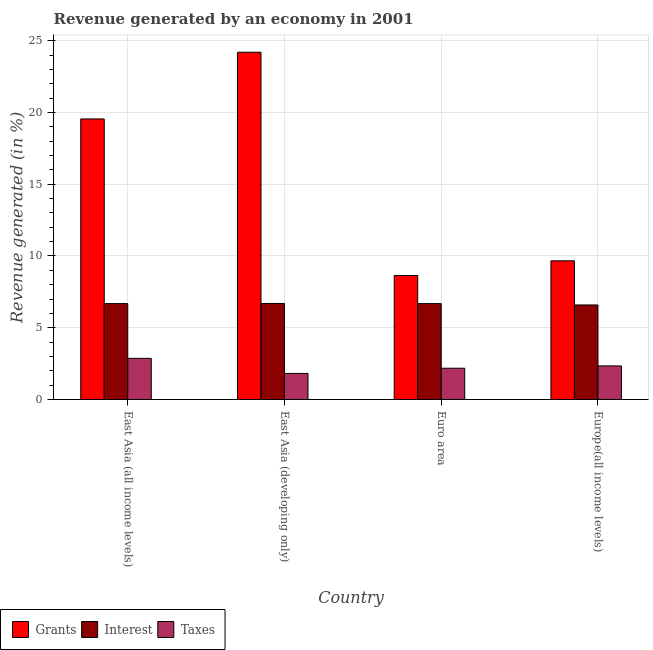How many different coloured bars are there?
Ensure brevity in your answer.  3. Are the number of bars per tick equal to the number of legend labels?
Your answer should be very brief. Yes. Are the number of bars on each tick of the X-axis equal?
Offer a very short reply. Yes. How many bars are there on the 2nd tick from the left?
Offer a terse response. 3. How many bars are there on the 1st tick from the right?
Offer a very short reply. 3. What is the label of the 3rd group of bars from the left?
Your answer should be very brief. Euro area. In how many cases, is the number of bars for a given country not equal to the number of legend labels?
Your answer should be compact. 0. What is the percentage of revenue generated by taxes in Euro area?
Give a very brief answer. 2.18. Across all countries, what is the maximum percentage of revenue generated by grants?
Offer a terse response. 24.19. Across all countries, what is the minimum percentage of revenue generated by interest?
Provide a short and direct response. 6.59. In which country was the percentage of revenue generated by grants maximum?
Ensure brevity in your answer.  East Asia (developing only). In which country was the percentage of revenue generated by grants minimum?
Provide a short and direct response. Euro area. What is the total percentage of revenue generated by grants in the graph?
Your response must be concise. 62.04. What is the difference between the percentage of revenue generated by taxes in East Asia (all income levels) and that in Europe(all income levels)?
Give a very brief answer. 0.53. What is the difference between the percentage of revenue generated by taxes in East Asia (developing only) and the percentage of revenue generated by grants in Europe(all income levels)?
Your response must be concise. -7.85. What is the average percentage of revenue generated by grants per country?
Offer a terse response. 15.51. What is the difference between the percentage of revenue generated by interest and percentage of revenue generated by grants in Europe(all income levels)?
Your response must be concise. -3.08. What is the ratio of the percentage of revenue generated by grants in East Asia (all income levels) to that in East Asia (developing only)?
Offer a very short reply. 0.81. What is the difference between the highest and the second highest percentage of revenue generated by taxes?
Provide a succinct answer. 0.53. What is the difference between the highest and the lowest percentage of revenue generated by taxes?
Your answer should be very brief. 1.05. What does the 2nd bar from the left in Euro area represents?
Offer a terse response. Interest. What does the 3rd bar from the right in Europe(all income levels) represents?
Your answer should be very brief. Grants. How many bars are there?
Give a very brief answer. 12. Are all the bars in the graph horizontal?
Keep it short and to the point. No. Are the values on the major ticks of Y-axis written in scientific E-notation?
Provide a short and direct response. No. Does the graph contain any zero values?
Provide a succinct answer. No. Does the graph contain grids?
Keep it short and to the point. Yes. How many legend labels are there?
Your response must be concise. 3. How are the legend labels stacked?
Provide a succinct answer. Horizontal. What is the title of the graph?
Provide a succinct answer. Revenue generated by an economy in 2001. What is the label or title of the X-axis?
Offer a terse response. Country. What is the label or title of the Y-axis?
Ensure brevity in your answer.  Revenue generated (in %). What is the Revenue generated (in %) of Grants in East Asia (all income levels)?
Provide a short and direct response. 19.55. What is the Revenue generated (in %) in Interest in East Asia (all income levels)?
Offer a very short reply. 6.68. What is the Revenue generated (in %) in Taxes in East Asia (all income levels)?
Provide a succinct answer. 2.87. What is the Revenue generated (in %) in Grants in East Asia (developing only)?
Your response must be concise. 24.19. What is the Revenue generated (in %) in Interest in East Asia (developing only)?
Ensure brevity in your answer.  6.69. What is the Revenue generated (in %) in Taxes in East Asia (developing only)?
Your answer should be very brief. 1.82. What is the Revenue generated (in %) of Grants in Euro area?
Your answer should be compact. 8.64. What is the Revenue generated (in %) of Interest in Euro area?
Give a very brief answer. 6.68. What is the Revenue generated (in %) of Taxes in Euro area?
Your response must be concise. 2.18. What is the Revenue generated (in %) in Grants in Europe(all income levels)?
Keep it short and to the point. 9.66. What is the Revenue generated (in %) in Interest in Europe(all income levels)?
Your response must be concise. 6.59. What is the Revenue generated (in %) in Taxes in Europe(all income levels)?
Offer a very short reply. 2.34. Across all countries, what is the maximum Revenue generated (in %) in Grants?
Your response must be concise. 24.19. Across all countries, what is the maximum Revenue generated (in %) in Interest?
Give a very brief answer. 6.69. Across all countries, what is the maximum Revenue generated (in %) in Taxes?
Provide a succinct answer. 2.87. Across all countries, what is the minimum Revenue generated (in %) in Grants?
Provide a short and direct response. 8.64. Across all countries, what is the minimum Revenue generated (in %) in Interest?
Provide a succinct answer. 6.59. Across all countries, what is the minimum Revenue generated (in %) in Taxes?
Provide a short and direct response. 1.82. What is the total Revenue generated (in %) of Grants in the graph?
Keep it short and to the point. 62.04. What is the total Revenue generated (in %) in Interest in the graph?
Your response must be concise. 26.64. What is the total Revenue generated (in %) in Taxes in the graph?
Offer a terse response. 9.21. What is the difference between the Revenue generated (in %) in Grants in East Asia (all income levels) and that in East Asia (developing only)?
Keep it short and to the point. -4.65. What is the difference between the Revenue generated (in %) in Interest in East Asia (all income levels) and that in East Asia (developing only)?
Keep it short and to the point. -0.01. What is the difference between the Revenue generated (in %) in Taxes in East Asia (all income levels) and that in East Asia (developing only)?
Provide a short and direct response. 1.05. What is the difference between the Revenue generated (in %) of Grants in East Asia (all income levels) and that in Euro area?
Provide a succinct answer. 10.91. What is the difference between the Revenue generated (in %) in Taxes in East Asia (all income levels) and that in Euro area?
Your answer should be compact. 0.69. What is the difference between the Revenue generated (in %) in Grants in East Asia (all income levels) and that in Europe(all income levels)?
Provide a succinct answer. 9.88. What is the difference between the Revenue generated (in %) in Interest in East Asia (all income levels) and that in Europe(all income levels)?
Offer a terse response. 0.09. What is the difference between the Revenue generated (in %) of Taxes in East Asia (all income levels) and that in Europe(all income levels)?
Make the answer very short. 0.53. What is the difference between the Revenue generated (in %) of Grants in East Asia (developing only) and that in Euro area?
Offer a very short reply. 15.55. What is the difference between the Revenue generated (in %) of Interest in East Asia (developing only) and that in Euro area?
Make the answer very short. 0.01. What is the difference between the Revenue generated (in %) of Taxes in East Asia (developing only) and that in Euro area?
Provide a succinct answer. -0.36. What is the difference between the Revenue generated (in %) in Grants in East Asia (developing only) and that in Europe(all income levels)?
Give a very brief answer. 14.53. What is the difference between the Revenue generated (in %) of Interest in East Asia (developing only) and that in Europe(all income levels)?
Your answer should be compact. 0.1. What is the difference between the Revenue generated (in %) in Taxes in East Asia (developing only) and that in Europe(all income levels)?
Ensure brevity in your answer.  -0.52. What is the difference between the Revenue generated (in %) of Grants in Euro area and that in Europe(all income levels)?
Your answer should be very brief. -1.02. What is the difference between the Revenue generated (in %) of Interest in Euro area and that in Europe(all income levels)?
Ensure brevity in your answer.  0.09. What is the difference between the Revenue generated (in %) in Taxes in Euro area and that in Europe(all income levels)?
Offer a very short reply. -0.16. What is the difference between the Revenue generated (in %) in Grants in East Asia (all income levels) and the Revenue generated (in %) in Interest in East Asia (developing only)?
Ensure brevity in your answer.  12.85. What is the difference between the Revenue generated (in %) in Grants in East Asia (all income levels) and the Revenue generated (in %) in Taxes in East Asia (developing only)?
Make the answer very short. 17.73. What is the difference between the Revenue generated (in %) of Interest in East Asia (all income levels) and the Revenue generated (in %) of Taxes in East Asia (developing only)?
Provide a succinct answer. 4.86. What is the difference between the Revenue generated (in %) in Grants in East Asia (all income levels) and the Revenue generated (in %) in Interest in Euro area?
Make the answer very short. 12.86. What is the difference between the Revenue generated (in %) in Grants in East Asia (all income levels) and the Revenue generated (in %) in Taxes in Euro area?
Offer a terse response. 17.37. What is the difference between the Revenue generated (in %) in Interest in East Asia (all income levels) and the Revenue generated (in %) in Taxes in Euro area?
Make the answer very short. 4.5. What is the difference between the Revenue generated (in %) of Grants in East Asia (all income levels) and the Revenue generated (in %) of Interest in Europe(all income levels)?
Your answer should be compact. 12.96. What is the difference between the Revenue generated (in %) in Grants in East Asia (all income levels) and the Revenue generated (in %) in Taxes in Europe(all income levels)?
Ensure brevity in your answer.  17.2. What is the difference between the Revenue generated (in %) in Interest in East Asia (all income levels) and the Revenue generated (in %) in Taxes in Europe(all income levels)?
Provide a succinct answer. 4.34. What is the difference between the Revenue generated (in %) in Grants in East Asia (developing only) and the Revenue generated (in %) in Interest in Euro area?
Keep it short and to the point. 17.51. What is the difference between the Revenue generated (in %) of Grants in East Asia (developing only) and the Revenue generated (in %) of Taxes in Euro area?
Your response must be concise. 22.01. What is the difference between the Revenue generated (in %) in Interest in East Asia (developing only) and the Revenue generated (in %) in Taxes in Euro area?
Offer a very short reply. 4.51. What is the difference between the Revenue generated (in %) of Grants in East Asia (developing only) and the Revenue generated (in %) of Interest in Europe(all income levels)?
Provide a succinct answer. 17.61. What is the difference between the Revenue generated (in %) of Grants in East Asia (developing only) and the Revenue generated (in %) of Taxes in Europe(all income levels)?
Offer a terse response. 21.85. What is the difference between the Revenue generated (in %) of Interest in East Asia (developing only) and the Revenue generated (in %) of Taxes in Europe(all income levels)?
Your answer should be very brief. 4.35. What is the difference between the Revenue generated (in %) in Grants in Euro area and the Revenue generated (in %) in Interest in Europe(all income levels)?
Give a very brief answer. 2.05. What is the difference between the Revenue generated (in %) in Grants in Euro area and the Revenue generated (in %) in Taxes in Europe(all income levels)?
Your answer should be compact. 6.3. What is the difference between the Revenue generated (in %) of Interest in Euro area and the Revenue generated (in %) of Taxes in Europe(all income levels)?
Offer a very short reply. 4.34. What is the average Revenue generated (in %) of Grants per country?
Ensure brevity in your answer.  15.51. What is the average Revenue generated (in %) of Interest per country?
Make the answer very short. 6.66. What is the average Revenue generated (in %) in Taxes per country?
Your response must be concise. 2.3. What is the difference between the Revenue generated (in %) in Grants and Revenue generated (in %) in Interest in East Asia (all income levels)?
Give a very brief answer. 12.86. What is the difference between the Revenue generated (in %) of Grants and Revenue generated (in %) of Taxes in East Asia (all income levels)?
Provide a short and direct response. 16.68. What is the difference between the Revenue generated (in %) in Interest and Revenue generated (in %) in Taxes in East Asia (all income levels)?
Your answer should be compact. 3.81. What is the difference between the Revenue generated (in %) in Grants and Revenue generated (in %) in Interest in East Asia (developing only)?
Your response must be concise. 17.5. What is the difference between the Revenue generated (in %) of Grants and Revenue generated (in %) of Taxes in East Asia (developing only)?
Offer a very short reply. 22.38. What is the difference between the Revenue generated (in %) in Interest and Revenue generated (in %) in Taxes in East Asia (developing only)?
Make the answer very short. 4.87. What is the difference between the Revenue generated (in %) in Grants and Revenue generated (in %) in Interest in Euro area?
Ensure brevity in your answer.  1.96. What is the difference between the Revenue generated (in %) of Grants and Revenue generated (in %) of Taxes in Euro area?
Give a very brief answer. 6.46. What is the difference between the Revenue generated (in %) of Interest and Revenue generated (in %) of Taxes in Euro area?
Your answer should be compact. 4.5. What is the difference between the Revenue generated (in %) of Grants and Revenue generated (in %) of Interest in Europe(all income levels)?
Keep it short and to the point. 3.08. What is the difference between the Revenue generated (in %) of Grants and Revenue generated (in %) of Taxes in Europe(all income levels)?
Provide a succinct answer. 7.32. What is the difference between the Revenue generated (in %) of Interest and Revenue generated (in %) of Taxes in Europe(all income levels)?
Offer a terse response. 4.25. What is the ratio of the Revenue generated (in %) in Grants in East Asia (all income levels) to that in East Asia (developing only)?
Your answer should be compact. 0.81. What is the ratio of the Revenue generated (in %) in Taxes in East Asia (all income levels) to that in East Asia (developing only)?
Provide a short and direct response. 1.58. What is the ratio of the Revenue generated (in %) of Grants in East Asia (all income levels) to that in Euro area?
Ensure brevity in your answer.  2.26. What is the ratio of the Revenue generated (in %) in Interest in East Asia (all income levels) to that in Euro area?
Give a very brief answer. 1. What is the ratio of the Revenue generated (in %) in Taxes in East Asia (all income levels) to that in Euro area?
Your answer should be very brief. 1.32. What is the ratio of the Revenue generated (in %) in Grants in East Asia (all income levels) to that in Europe(all income levels)?
Your response must be concise. 2.02. What is the ratio of the Revenue generated (in %) in Interest in East Asia (all income levels) to that in Europe(all income levels)?
Your answer should be compact. 1.01. What is the ratio of the Revenue generated (in %) in Taxes in East Asia (all income levels) to that in Europe(all income levels)?
Provide a short and direct response. 1.23. What is the ratio of the Revenue generated (in %) in Grants in East Asia (developing only) to that in Euro area?
Give a very brief answer. 2.8. What is the ratio of the Revenue generated (in %) in Interest in East Asia (developing only) to that in Euro area?
Make the answer very short. 1. What is the ratio of the Revenue generated (in %) in Taxes in East Asia (developing only) to that in Euro area?
Make the answer very short. 0.83. What is the ratio of the Revenue generated (in %) in Grants in East Asia (developing only) to that in Europe(all income levels)?
Provide a succinct answer. 2.5. What is the ratio of the Revenue generated (in %) in Interest in East Asia (developing only) to that in Europe(all income levels)?
Ensure brevity in your answer.  1.02. What is the ratio of the Revenue generated (in %) in Taxes in East Asia (developing only) to that in Europe(all income levels)?
Provide a succinct answer. 0.78. What is the ratio of the Revenue generated (in %) in Grants in Euro area to that in Europe(all income levels)?
Your answer should be compact. 0.89. What is the ratio of the Revenue generated (in %) of Interest in Euro area to that in Europe(all income levels)?
Provide a short and direct response. 1.01. What is the ratio of the Revenue generated (in %) in Taxes in Euro area to that in Europe(all income levels)?
Offer a very short reply. 0.93. What is the difference between the highest and the second highest Revenue generated (in %) in Grants?
Your answer should be compact. 4.65. What is the difference between the highest and the second highest Revenue generated (in %) of Interest?
Your answer should be compact. 0.01. What is the difference between the highest and the second highest Revenue generated (in %) of Taxes?
Ensure brevity in your answer.  0.53. What is the difference between the highest and the lowest Revenue generated (in %) in Grants?
Provide a short and direct response. 15.55. What is the difference between the highest and the lowest Revenue generated (in %) in Interest?
Ensure brevity in your answer.  0.1. What is the difference between the highest and the lowest Revenue generated (in %) in Taxes?
Ensure brevity in your answer.  1.05. 